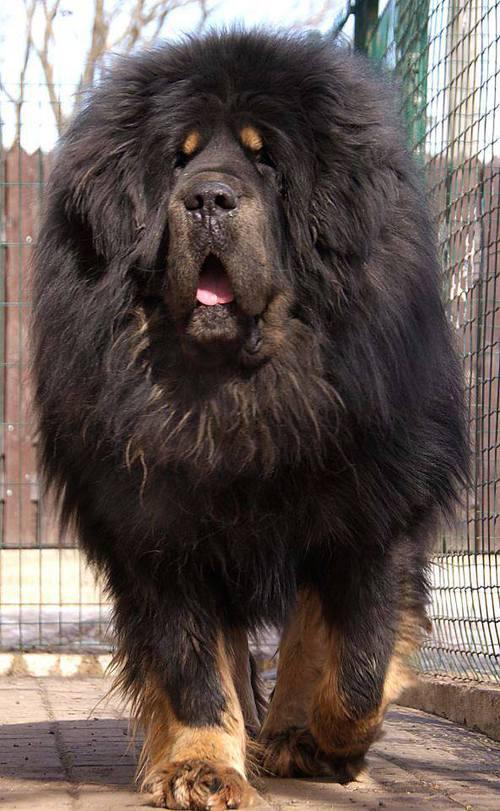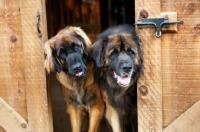The first image is the image on the left, the second image is the image on the right. Examine the images to the left and right. Is the description "There are at most two dogs." accurate? Answer yes or no. No. The first image is the image on the left, the second image is the image on the right. Analyze the images presented: Is the assertion "There are a total of exactly two dogs." valid? Answer yes or no. No. 